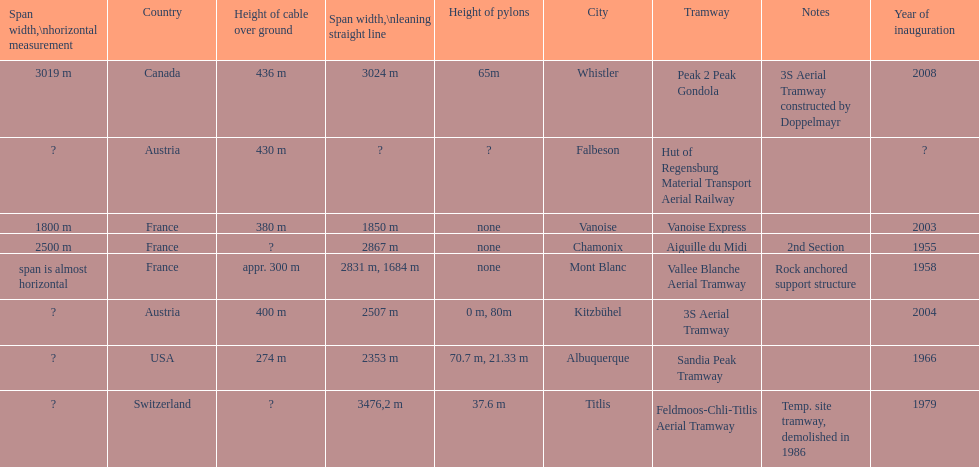Which tramway was built directly before the 3s aeriral tramway? Vanoise Express. 